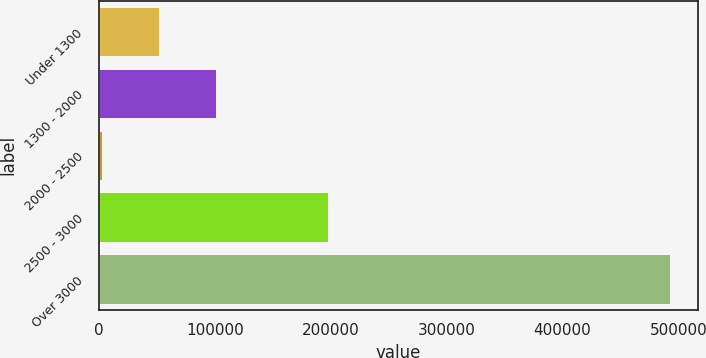<chart> <loc_0><loc_0><loc_500><loc_500><bar_chart><fcel>Under 1300<fcel>1300 - 2000<fcel>2000 - 2500<fcel>2500 - 3000<fcel>Over 3000<nl><fcel>51675.9<fcel>100685<fcel>2667<fcel>197750<fcel>492756<nl></chart> 